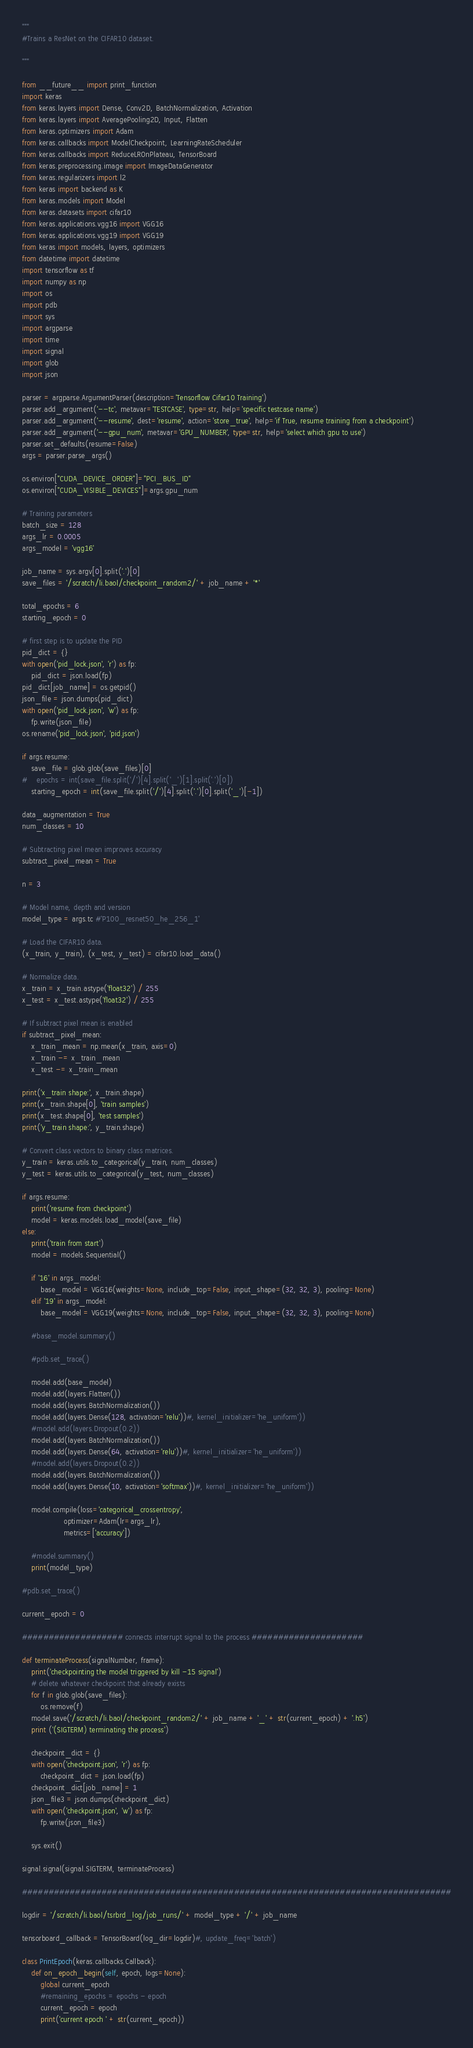<code> <loc_0><loc_0><loc_500><loc_500><_Python_>"""
#Trains a ResNet on the CIFAR10 dataset.

"""

from __future__ import print_function
import keras
from keras.layers import Dense, Conv2D, BatchNormalization, Activation
from keras.layers import AveragePooling2D, Input, Flatten
from keras.optimizers import Adam
from keras.callbacks import ModelCheckpoint, LearningRateScheduler
from keras.callbacks import ReduceLROnPlateau, TensorBoard
from keras.preprocessing.image import ImageDataGenerator
from keras.regularizers import l2
from keras import backend as K
from keras.models import Model
from keras.datasets import cifar10
from keras.applications.vgg16 import VGG16
from keras.applications.vgg19 import VGG19
from keras import models, layers, optimizers
from datetime import datetime
import tensorflow as tf
import numpy as np
import os
import pdb
import sys
import argparse
import time
import signal
import glob
import json

parser = argparse.ArgumentParser(description='Tensorflow Cifar10 Training')
parser.add_argument('--tc', metavar='TESTCASE', type=str, help='specific testcase name')
parser.add_argument('--resume', dest='resume', action='store_true', help='if True, resume training from a checkpoint')
parser.add_argument('--gpu_num', metavar='GPU_NUMBER', type=str, help='select which gpu to use')
parser.set_defaults(resume=False)
args = parser.parse_args()

os.environ["CUDA_DEVICE_ORDER"]="PCI_BUS_ID"
os.environ["CUDA_VISIBLE_DEVICES"]=args.gpu_num

# Training parameters
batch_size = 128
args_lr = 0.0005
args_model = 'vgg16'

job_name = sys.argv[0].split('.')[0]
save_files = '/scratch/li.baol/checkpoint_random2/' + job_name + '*'

total_epochs = 6
starting_epoch = 0

# first step is to update the PID
pid_dict = {}
with open('pid_lock.json', 'r') as fp:
    pid_dict = json.load(fp)
pid_dict[job_name] = os.getpid()
json_file = json.dumps(pid_dict)
with open('pid_lock.json', 'w') as fp:
    fp.write(json_file) 
os.rename('pid_lock.json', 'pid.json')

if args.resume:
    save_file = glob.glob(save_files)[0]
#    epochs = int(save_file.split('/')[4].split('_')[1].split('.')[0])
    starting_epoch = int(save_file.split('/')[4].split('.')[0].split('_')[-1])

data_augmentation = True
num_classes = 10

# Subtracting pixel mean improves accuracy
subtract_pixel_mean = True

n = 3

# Model name, depth and version
model_type = args.tc #'P100_resnet50_he_256_1'

# Load the CIFAR10 data.
(x_train, y_train), (x_test, y_test) = cifar10.load_data()

# Normalize data.
x_train = x_train.astype('float32') / 255
x_test = x_test.astype('float32') / 255

# If subtract pixel mean is enabled
if subtract_pixel_mean:
    x_train_mean = np.mean(x_train, axis=0)
    x_train -= x_train_mean
    x_test -= x_train_mean

print('x_train shape:', x_train.shape)
print(x_train.shape[0], 'train samples')
print(x_test.shape[0], 'test samples')
print('y_train shape:', y_train.shape)

# Convert class vectors to binary class matrices.
y_train = keras.utils.to_categorical(y_train, num_classes)
y_test = keras.utils.to_categorical(y_test, num_classes)

if args.resume:
    print('resume from checkpoint')
    model = keras.models.load_model(save_file)
else:
    print('train from start')
    model = models.Sequential()
    
    if '16' in args_model:
        base_model = VGG16(weights=None, include_top=False, input_shape=(32, 32, 3), pooling=None)
    elif '19' in args_model:
        base_model = VGG19(weights=None, include_top=False, input_shape=(32, 32, 3), pooling=None)
    
    #base_model.summary()
    
    #pdb.set_trace()
    
    model.add(base_model)
    model.add(layers.Flatten())
    model.add(layers.BatchNormalization())
    model.add(layers.Dense(128, activation='relu'))#, kernel_initializer='he_uniform'))
    #model.add(layers.Dropout(0.2))
    model.add(layers.BatchNormalization())
    model.add(layers.Dense(64, activation='relu'))#, kernel_initializer='he_uniform'))
    #model.add(layers.Dropout(0.2))
    model.add(layers.BatchNormalization())
    model.add(layers.Dense(10, activation='softmax'))#, kernel_initializer='he_uniform'))
    
    model.compile(loss='categorical_crossentropy',
                  optimizer=Adam(lr=args_lr),
                  metrics=['accuracy'])
    
    #model.summary()
    print(model_type)

#pdb.set_trace()

current_epoch = 0

################### connects interrupt signal to the process #####################

def terminateProcess(signalNumber, frame):
    print('checkpointing the model triggered by kill -15 signal')
    # delete whatever checkpoint that already exists
    for f in glob.glob(save_files):
        os.remove(f)
    model.save('/scratch/li.baol/checkpoint_random2/' + job_name + '_' + str(current_epoch) + '.h5')
    print ('(SIGTERM) terminating the process')

    checkpoint_dict = {}
    with open('checkpoint.json', 'r') as fp:
        checkpoint_dict = json.load(fp)
    checkpoint_dict[job_name] = 1
    json_file3 = json.dumps(checkpoint_dict)
    with open('checkpoint.json', 'w') as fp:
        fp.write(json_file3)

    sys.exit()

signal.signal(signal.SIGTERM, terminateProcess)

#################################################################################

logdir = '/scratch/li.baol/tsrbrd_log/job_runs/' + model_type + '/' + job_name

tensorboard_callback = TensorBoard(log_dir=logdir)#, update_freq='batch')

class PrintEpoch(keras.callbacks.Callback):
    def on_epoch_begin(self, epoch, logs=None):
        global current_epoch 
        #remaining_epochs = epochs - epoch
        current_epoch = epoch
        print('current epoch ' + str(current_epoch))
</code> 